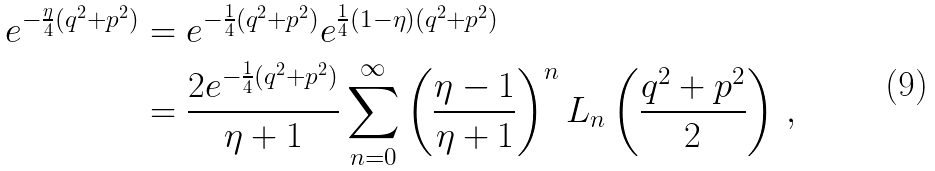<formula> <loc_0><loc_0><loc_500><loc_500>e ^ { - \frac { \eta } { 4 } ( q ^ { 2 } + p ^ { 2 } ) } & = e ^ { - \frac { 1 } { 4 } ( q ^ { 2 } + p ^ { 2 } ) } e ^ { \frac { 1 } { 4 } ( 1 - \eta ) ( q ^ { 2 } + p ^ { 2 } ) } \\ & = \frac { 2 e ^ { - \frac { 1 } { 4 } ( q ^ { 2 } + p ^ { 2 } ) } } { \eta + 1 } \sum _ { n = 0 } ^ { \infty } \left ( \frac { \eta - 1 } { \eta + 1 } \right ) ^ { n } L _ { n } \left ( \frac { q ^ { 2 } + p ^ { 2 } } 2 \right ) \, ,</formula> 